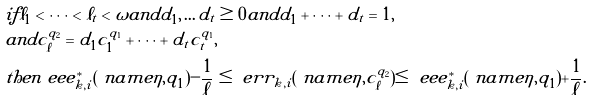Convert formula to latex. <formula><loc_0><loc_0><loc_500><loc_500>& i f \ell _ { 1 } < \cdots < \ell _ { t } < \omega a n d d _ { 1 } , \dots d _ { t } \geq 0 a n d d _ { 1 } + \cdots + d _ { t } = 1 , \\ & a n d c _ { \ell } ^ { q _ { 2 } } = d _ { 1 } c _ { 1 } ^ { q _ { 1 } } + \cdots + d _ { t } c _ { t } ^ { q _ { 1 } } , \\ & t h e n \ e e e ^ { * } _ { k , i } ( \ n a m e { \eta } , q _ { 1 } ) - \frac { 1 } { \ell } \leq \ e r r _ { k , i } ( \ n a m e { \eta } , c _ { \ell } ^ { q _ { 2 } } ) \leq \ e e e ^ { * } _ { k , i } ( \ n a m e { \eta } , q _ { 1 } ) + \frac { 1 } { \ell } .</formula> 